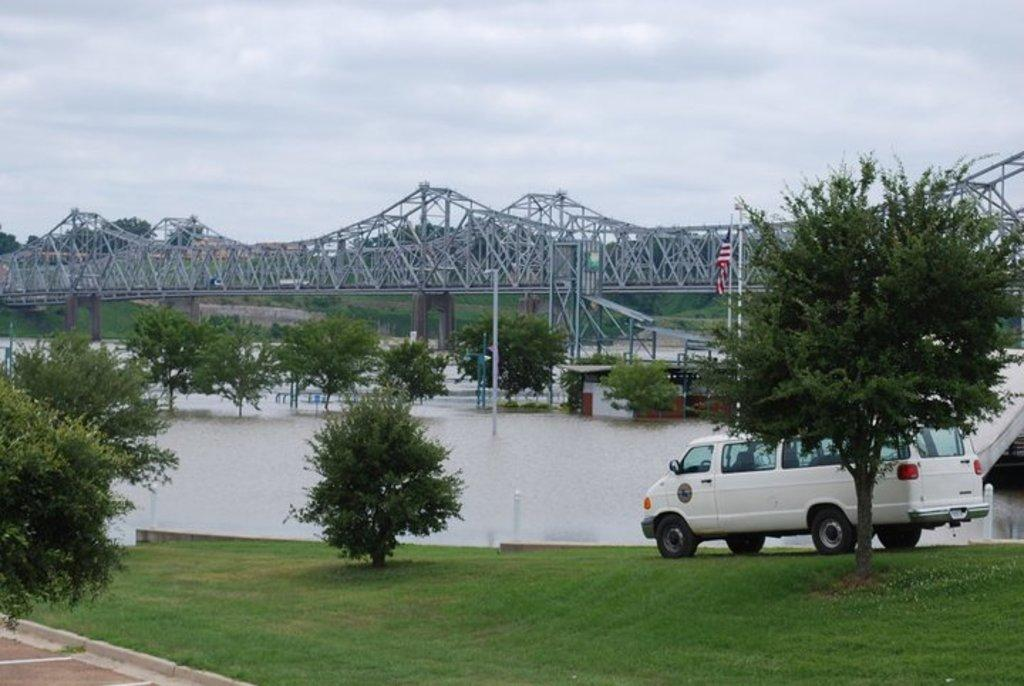What type of vegetation can be seen in the image? There are plants and grass visible in the image. What is on the ground in the image? There is a vehicle on the ground. What can be seen in the background of the image? There is a bridge, trees, water, a flag pole, ropes, and clouds in the background of the image. How far away is the honey from the vehicle in the image? There is no honey present in the image, so it cannot be determined how far away it might be from the vehicle. Can you describe the running activity in the image? There is no running activity depicted in the image; it features plants, grass, a vehicle, a bridge, trees, water, a flag pole, ropes, and clouds. 